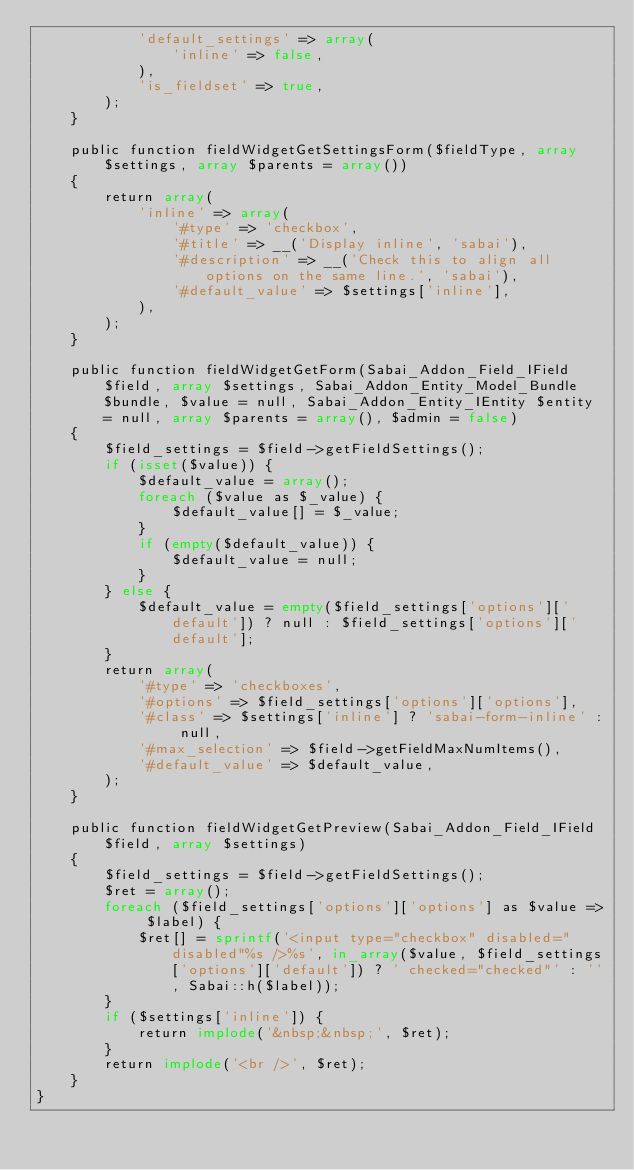<code> <loc_0><loc_0><loc_500><loc_500><_PHP_>            'default_settings' => array(
                'inline' => false,
            ),
            'is_fieldset' => true,
        );
    }

    public function fieldWidgetGetSettingsForm($fieldType, array $settings, array $parents = array())
    {
        return array(
            'inline' => array(
                '#type' => 'checkbox',
                '#title' => __('Display inline', 'sabai'),
                '#description' => __('Check this to align all options on the same line.', 'sabai'),
                '#default_value' => $settings['inline'],
            ),
        );
    }

    public function fieldWidgetGetForm(Sabai_Addon_Field_IField $field, array $settings, Sabai_Addon_Entity_Model_Bundle $bundle, $value = null, Sabai_Addon_Entity_IEntity $entity = null, array $parents = array(), $admin = false)
    {
        $field_settings = $field->getFieldSettings();
        if (isset($value)) {
            $default_value = array();
            foreach ($value as $_value) {
                $default_value[] = $_value;
            }
            if (empty($default_value)) {
                $default_value = null; 
            }
        } else {
            $default_value = empty($field_settings['options']['default']) ? null : $field_settings['options']['default']; 
        }
        return array(
            '#type' => 'checkboxes',
            '#options' => $field_settings['options']['options'],
            '#class' => $settings['inline'] ? 'sabai-form-inline' : null,
            '#max_selection' => $field->getFieldMaxNumItems(),
            '#default_value' => $default_value,
        );
    }
        
    public function fieldWidgetGetPreview(Sabai_Addon_Field_IField $field, array $settings)
    {
        $field_settings = $field->getFieldSettings();
        $ret = array();
        foreach ($field_settings['options']['options'] as $value => $label) {
            $ret[] = sprintf('<input type="checkbox" disabled="disabled"%s />%s', in_array($value, $field_settings['options']['default']) ? ' checked="checked"' : '', Sabai::h($label));
        }
        if ($settings['inline']) {
            return implode('&nbsp;&nbsp;', $ret);
        }
        return implode('<br />', $ret);
    }
}</code> 